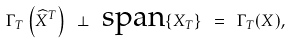Convert formula to latex. <formula><loc_0><loc_0><loc_500><loc_500>\Gamma _ { T } \left ( \widehat { X } ^ { T } \right ) \ \perp \ \text {span} \{ X _ { T } \} \ = \ \Gamma _ { T } ( X ) ,</formula> 